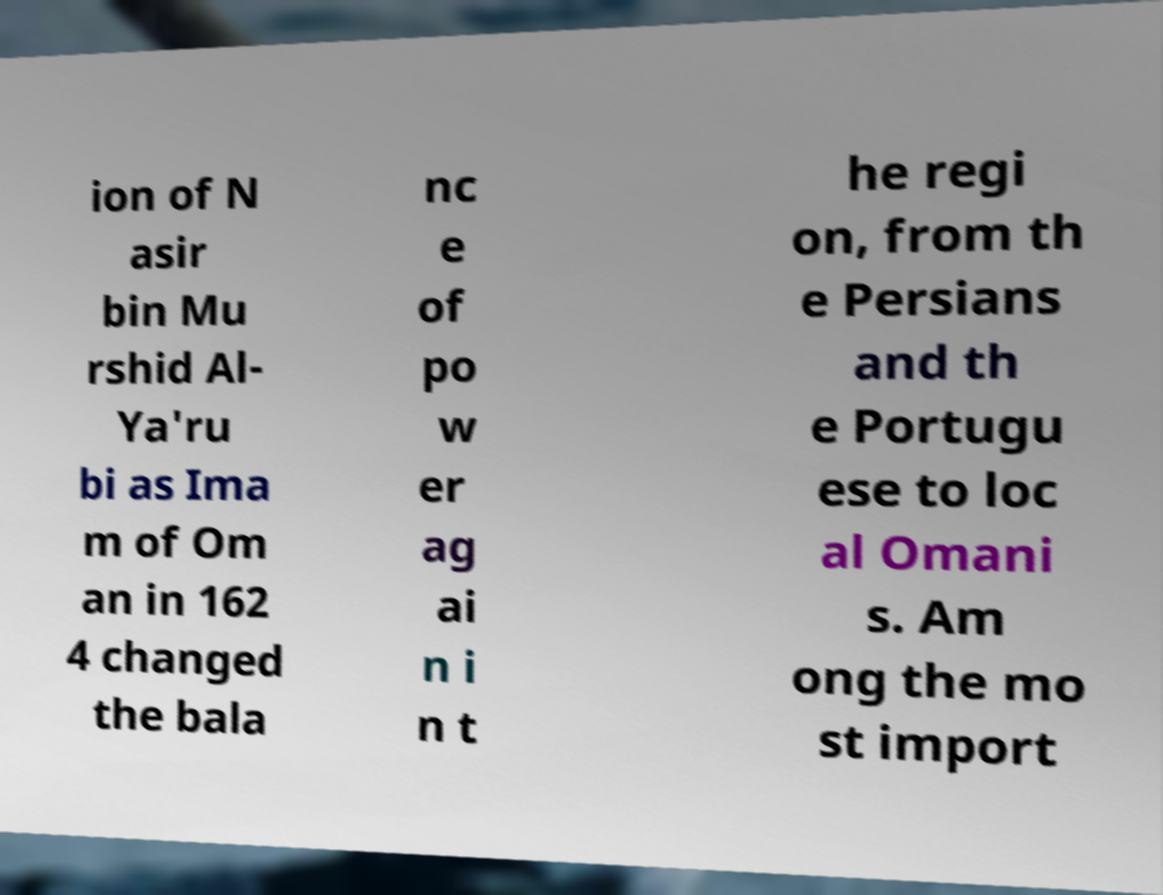Could you extract and type out the text from this image? ion of N asir bin Mu rshid Al- Ya'ru bi as Ima m of Om an in 162 4 changed the bala nc e of po w er ag ai n i n t he regi on, from th e Persians and th e Portugu ese to loc al Omani s. Am ong the mo st import 